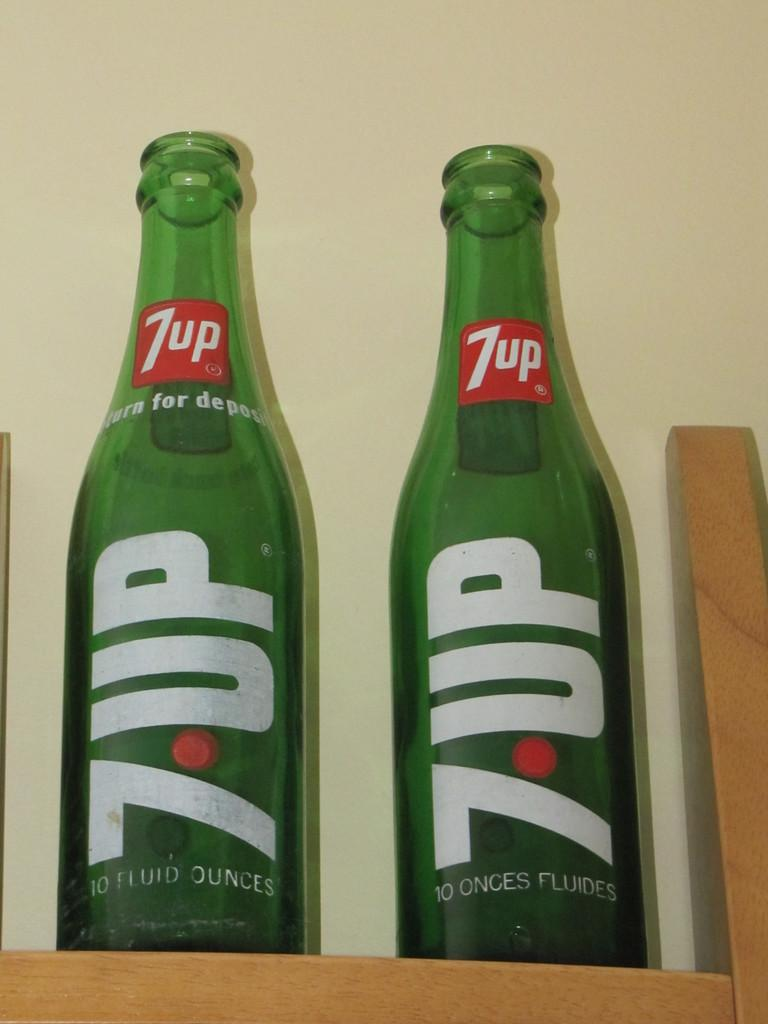<image>
Share a concise interpretation of the image provided. Two empty glass bottles of 7-UP are side by side on a wooden shelf. 